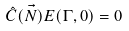Convert formula to latex. <formula><loc_0><loc_0><loc_500><loc_500>\hat { C } ( \vec { N } ) E ( \Gamma , 0 ) = 0</formula> 